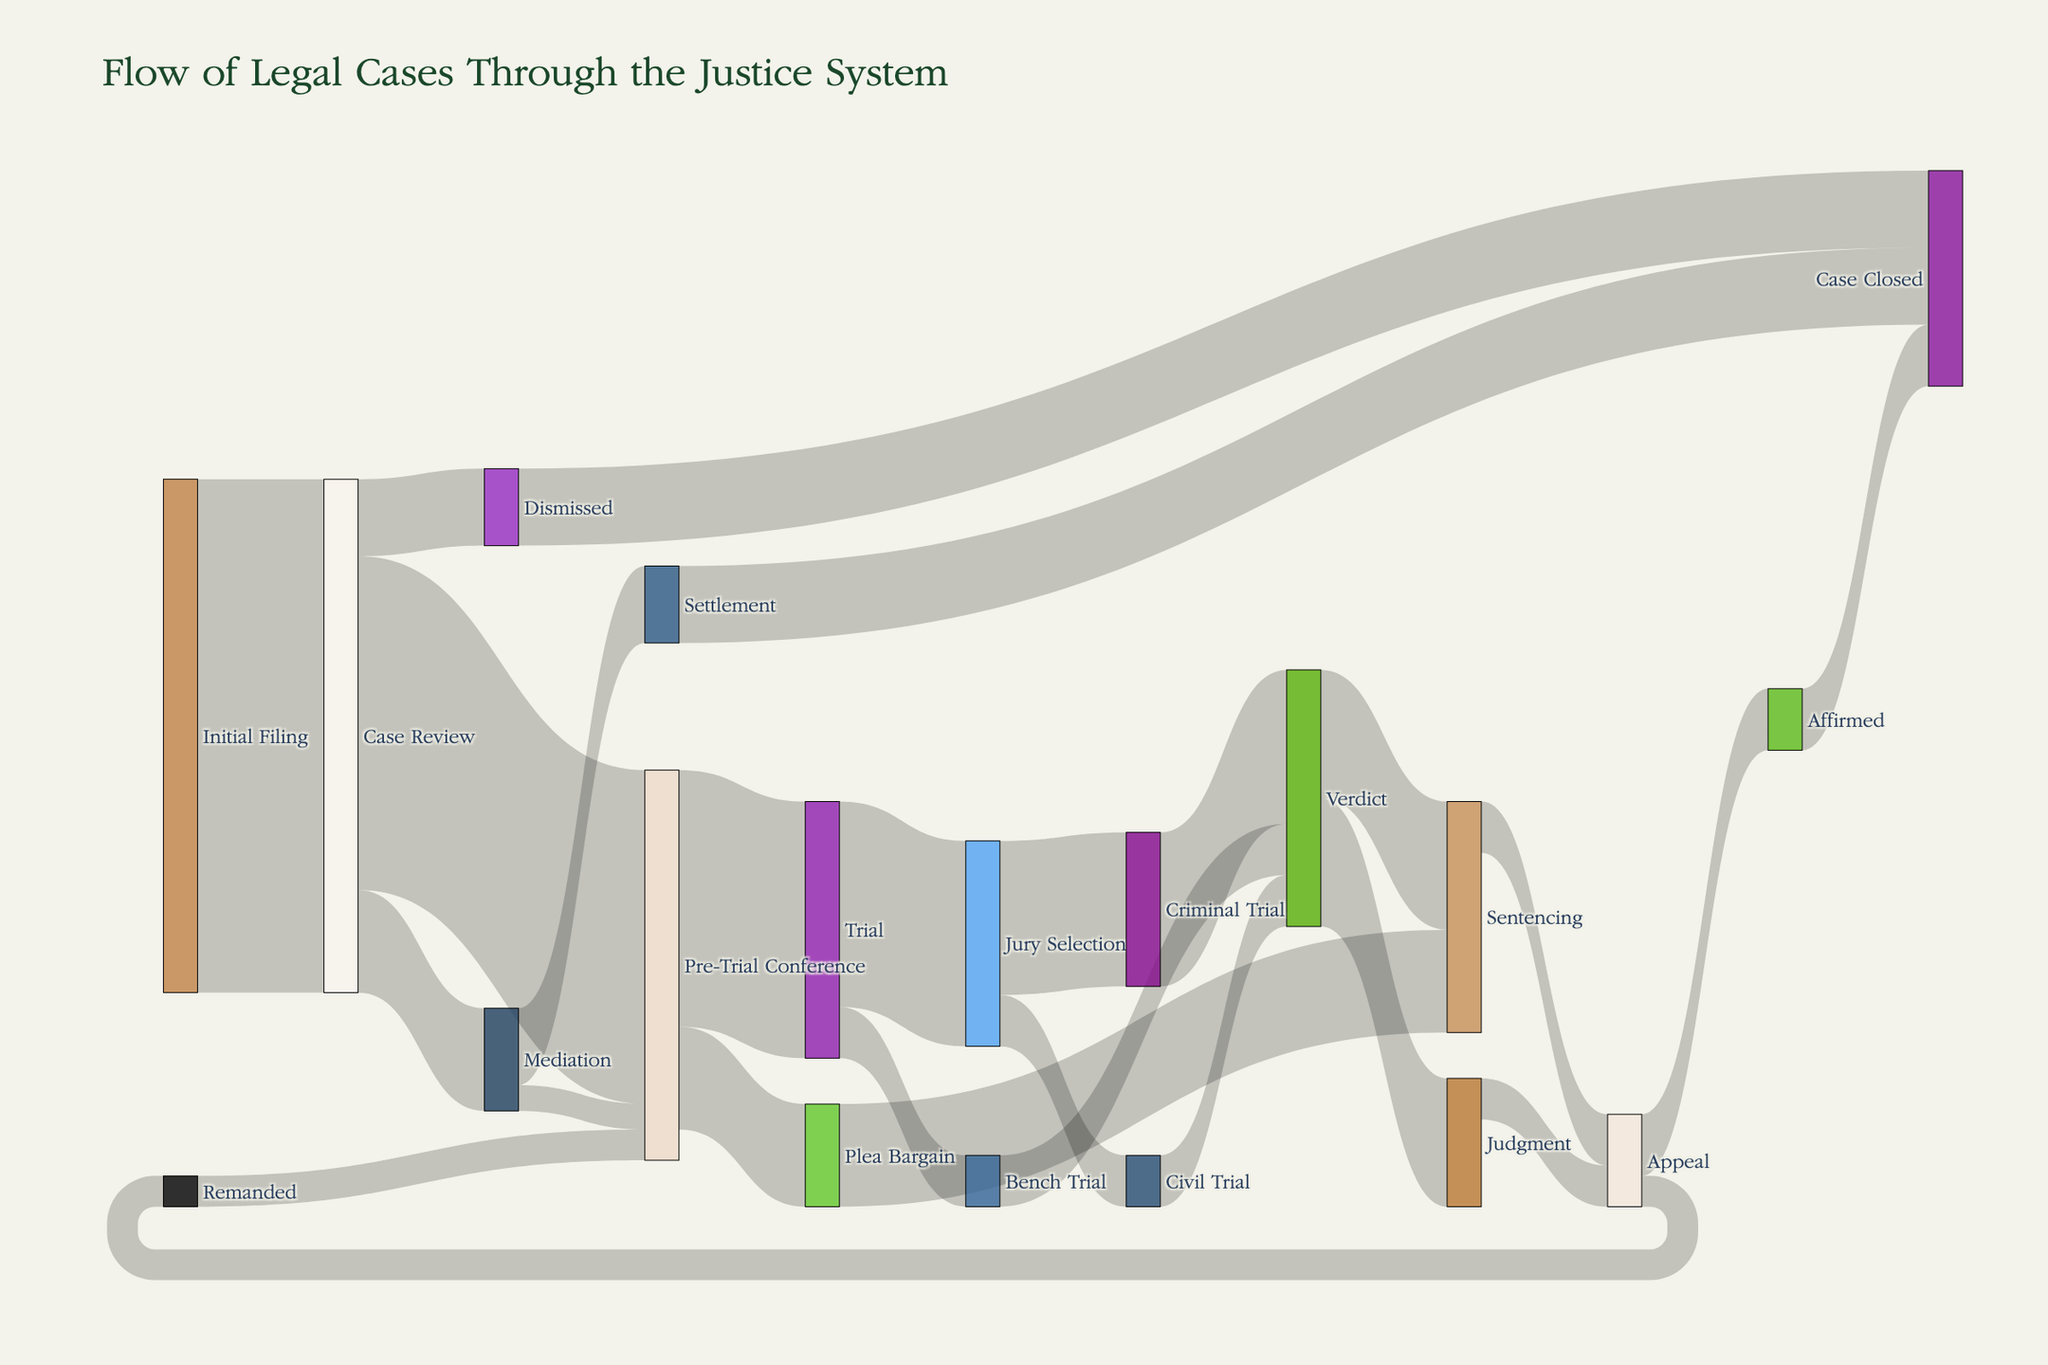How many cases were initially filed? The "Initial Filing" node represents the starting point of the legal cases. The total flow from this node indicates the number of initial filings. In the figure, the flow from "Initial Filing" to "Case Review" is 1000.
Answer: 1000 How many cases reached a settlement through mediation? From the figure, we follow the flow from "Mediation" to "Settlement." The flow value between these nodes is 150.
Answer: 150 Which outcome has more cases, dismissed or settled? The figure shows two nodes: "Dismissed" and "Settlement." The flow to "Dismissed" is 150, and the flow to "Settlement" is also 150.
Answer: Equal What is the total number of cases that go to trial? To find the total cases going to trial, we sum the flows to "Trial." There are two flows: "Pre-Trial Conference" to "Trial" with 500 cases, and "Mediation" to "Trial" with 50 cases. The total is 500 + 50.
Answer: 550 How many cases were remanded for a pre-trial conference? The "Remanded" node flows to "Pre-Trial Conference," and we must look at the flow value for this path. The figure shows a flow value of 60.
Answer: 60 After case review, do more cases go to a pre-trial conference or mediation? Following the paths from "Case Review," we see the flows to "Mediation" and "Pre-Trial Conference." The flow to "Mediation" is 200 and to "Pre-Trial Conference" is 650.
Answer: Pre-Trial Conference What portion of jury selected cases continues into a criminal trial? The total flow from "Jury Selection" is 400 (sum of 300 for "Criminal Trial" and 100 for "Civil Trial"). Percentage into "Criminal Trial" is (300/400 * 100).
Answer: 75% Which has a higher volume of cases: cases concluded via judgment or those sentenced? From the "Verdict" node, there are two flows: one to "Sentencing" with 250 cases and another to "Judgment" with 250 cases. Both volumes are the same.
Answer: Equal Which phase shows the highest attrition of cases from one step to the next? Comparing all the drops between nodes, the most significant decrease is from "Case Review" to its subsequent steps. From "Case Review" with 1000 cases, it reduces significantly with the highest drop to "Pre-Trial Conference" 650 cases, leaving 350 cases covered in other outcomes. Hence, "Case Review" to "Pre-Trial Conference".
Answer: Case Review to Pre-Trial Conference 